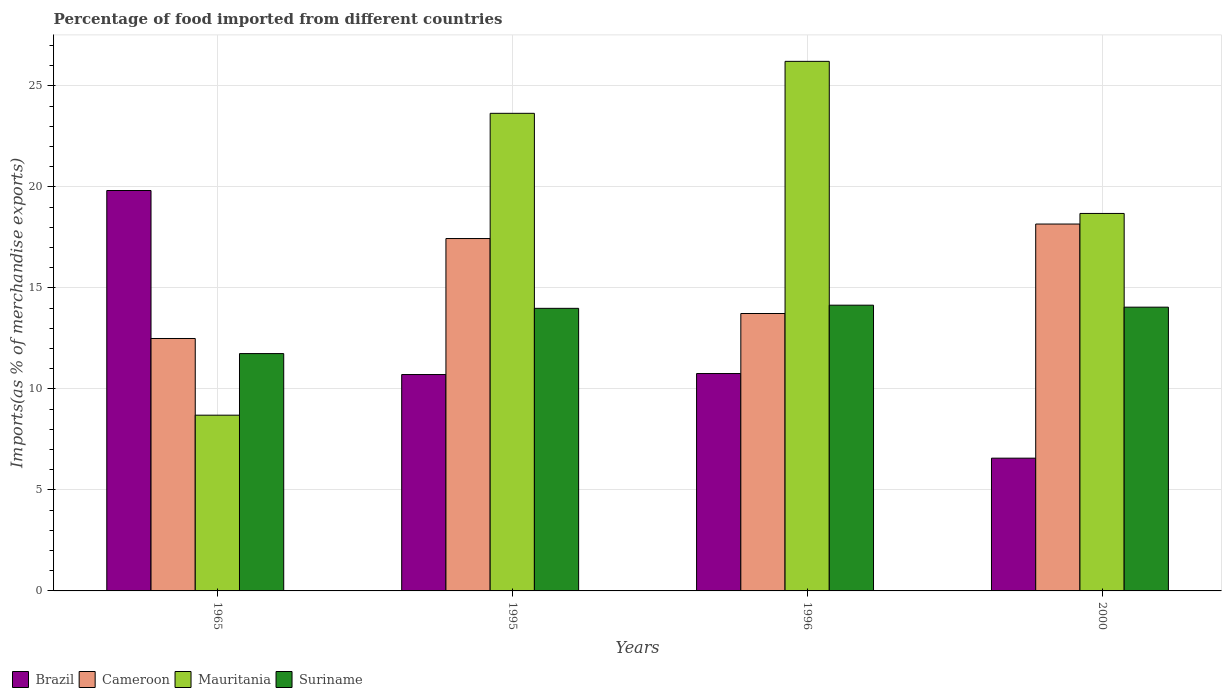How many different coloured bars are there?
Provide a short and direct response. 4. How many groups of bars are there?
Your answer should be very brief. 4. Are the number of bars on each tick of the X-axis equal?
Your answer should be very brief. Yes. How many bars are there on the 4th tick from the left?
Keep it short and to the point. 4. How many bars are there on the 2nd tick from the right?
Your answer should be very brief. 4. What is the percentage of imports to different countries in Suriname in 1995?
Make the answer very short. 13.99. Across all years, what is the maximum percentage of imports to different countries in Brazil?
Your response must be concise. 19.82. Across all years, what is the minimum percentage of imports to different countries in Suriname?
Provide a succinct answer. 11.75. In which year was the percentage of imports to different countries in Brazil maximum?
Provide a short and direct response. 1965. In which year was the percentage of imports to different countries in Cameroon minimum?
Give a very brief answer. 1965. What is the total percentage of imports to different countries in Suriname in the graph?
Offer a very short reply. 53.92. What is the difference between the percentage of imports to different countries in Brazil in 1965 and that in 2000?
Provide a short and direct response. 13.25. What is the difference between the percentage of imports to different countries in Cameroon in 2000 and the percentage of imports to different countries in Suriname in 1995?
Keep it short and to the point. 4.17. What is the average percentage of imports to different countries in Brazil per year?
Your answer should be very brief. 11.96. In the year 2000, what is the difference between the percentage of imports to different countries in Mauritania and percentage of imports to different countries in Cameroon?
Your answer should be very brief. 0.52. What is the ratio of the percentage of imports to different countries in Suriname in 1965 to that in 1995?
Provide a short and direct response. 0.84. Is the difference between the percentage of imports to different countries in Mauritania in 1965 and 2000 greater than the difference between the percentage of imports to different countries in Cameroon in 1965 and 2000?
Your response must be concise. No. What is the difference between the highest and the second highest percentage of imports to different countries in Brazil?
Give a very brief answer. 9.06. What is the difference between the highest and the lowest percentage of imports to different countries in Suriname?
Offer a very short reply. 2.4. In how many years, is the percentage of imports to different countries in Brazil greater than the average percentage of imports to different countries in Brazil taken over all years?
Ensure brevity in your answer.  1. Is the sum of the percentage of imports to different countries in Cameroon in 1965 and 1995 greater than the maximum percentage of imports to different countries in Suriname across all years?
Provide a succinct answer. Yes. What does the 4th bar from the right in 1995 represents?
Make the answer very short. Brazil. Is it the case that in every year, the sum of the percentage of imports to different countries in Mauritania and percentage of imports to different countries in Brazil is greater than the percentage of imports to different countries in Cameroon?
Your answer should be compact. Yes. Are all the bars in the graph horizontal?
Make the answer very short. No. What is the difference between two consecutive major ticks on the Y-axis?
Provide a succinct answer. 5. What is the title of the graph?
Provide a short and direct response. Percentage of food imported from different countries. Does "West Bank and Gaza" appear as one of the legend labels in the graph?
Your answer should be very brief. No. What is the label or title of the X-axis?
Provide a short and direct response. Years. What is the label or title of the Y-axis?
Ensure brevity in your answer.  Imports(as % of merchandise exports). What is the Imports(as % of merchandise exports) of Brazil in 1965?
Keep it short and to the point. 19.82. What is the Imports(as % of merchandise exports) of Cameroon in 1965?
Your response must be concise. 12.49. What is the Imports(as % of merchandise exports) of Mauritania in 1965?
Your response must be concise. 8.7. What is the Imports(as % of merchandise exports) of Suriname in 1965?
Provide a succinct answer. 11.75. What is the Imports(as % of merchandise exports) of Brazil in 1995?
Provide a short and direct response. 10.71. What is the Imports(as % of merchandise exports) of Cameroon in 1995?
Keep it short and to the point. 17.44. What is the Imports(as % of merchandise exports) in Mauritania in 1995?
Your response must be concise. 23.64. What is the Imports(as % of merchandise exports) of Suriname in 1995?
Your response must be concise. 13.99. What is the Imports(as % of merchandise exports) in Brazil in 1996?
Keep it short and to the point. 10.76. What is the Imports(as % of merchandise exports) in Cameroon in 1996?
Your answer should be compact. 13.73. What is the Imports(as % of merchandise exports) in Mauritania in 1996?
Ensure brevity in your answer.  26.21. What is the Imports(as % of merchandise exports) of Suriname in 1996?
Offer a terse response. 14.14. What is the Imports(as % of merchandise exports) in Brazil in 2000?
Offer a very short reply. 6.57. What is the Imports(as % of merchandise exports) in Cameroon in 2000?
Make the answer very short. 18.16. What is the Imports(as % of merchandise exports) in Mauritania in 2000?
Your response must be concise. 18.68. What is the Imports(as % of merchandise exports) of Suriname in 2000?
Provide a succinct answer. 14.04. Across all years, what is the maximum Imports(as % of merchandise exports) in Brazil?
Give a very brief answer. 19.82. Across all years, what is the maximum Imports(as % of merchandise exports) of Cameroon?
Provide a short and direct response. 18.16. Across all years, what is the maximum Imports(as % of merchandise exports) in Mauritania?
Provide a short and direct response. 26.21. Across all years, what is the maximum Imports(as % of merchandise exports) of Suriname?
Make the answer very short. 14.14. Across all years, what is the minimum Imports(as % of merchandise exports) in Brazil?
Offer a terse response. 6.57. Across all years, what is the minimum Imports(as % of merchandise exports) of Cameroon?
Give a very brief answer. 12.49. Across all years, what is the minimum Imports(as % of merchandise exports) in Mauritania?
Make the answer very short. 8.7. Across all years, what is the minimum Imports(as % of merchandise exports) in Suriname?
Provide a short and direct response. 11.75. What is the total Imports(as % of merchandise exports) of Brazil in the graph?
Keep it short and to the point. 47.86. What is the total Imports(as % of merchandise exports) in Cameroon in the graph?
Your answer should be compact. 61.82. What is the total Imports(as % of merchandise exports) in Mauritania in the graph?
Ensure brevity in your answer.  77.23. What is the total Imports(as % of merchandise exports) of Suriname in the graph?
Ensure brevity in your answer.  53.92. What is the difference between the Imports(as % of merchandise exports) in Brazil in 1965 and that in 1995?
Keep it short and to the point. 9.11. What is the difference between the Imports(as % of merchandise exports) in Cameroon in 1965 and that in 1995?
Keep it short and to the point. -4.95. What is the difference between the Imports(as % of merchandise exports) in Mauritania in 1965 and that in 1995?
Your answer should be very brief. -14.94. What is the difference between the Imports(as % of merchandise exports) in Suriname in 1965 and that in 1995?
Make the answer very short. -2.24. What is the difference between the Imports(as % of merchandise exports) of Brazil in 1965 and that in 1996?
Ensure brevity in your answer.  9.06. What is the difference between the Imports(as % of merchandise exports) in Cameroon in 1965 and that in 1996?
Give a very brief answer. -1.24. What is the difference between the Imports(as % of merchandise exports) in Mauritania in 1965 and that in 1996?
Make the answer very short. -17.51. What is the difference between the Imports(as % of merchandise exports) in Suriname in 1965 and that in 1996?
Provide a succinct answer. -2.4. What is the difference between the Imports(as % of merchandise exports) in Brazil in 1965 and that in 2000?
Give a very brief answer. 13.25. What is the difference between the Imports(as % of merchandise exports) of Cameroon in 1965 and that in 2000?
Ensure brevity in your answer.  -5.66. What is the difference between the Imports(as % of merchandise exports) in Mauritania in 1965 and that in 2000?
Keep it short and to the point. -9.98. What is the difference between the Imports(as % of merchandise exports) in Suriname in 1965 and that in 2000?
Ensure brevity in your answer.  -2.3. What is the difference between the Imports(as % of merchandise exports) in Brazil in 1995 and that in 1996?
Your answer should be compact. -0.05. What is the difference between the Imports(as % of merchandise exports) of Cameroon in 1995 and that in 1996?
Offer a terse response. 3.71. What is the difference between the Imports(as % of merchandise exports) in Mauritania in 1995 and that in 1996?
Your answer should be compact. -2.57. What is the difference between the Imports(as % of merchandise exports) in Suriname in 1995 and that in 1996?
Your response must be concise. -0.16. What is the difference between the Imports(as % of merchandise exports) of Brazil in 1995 and that in 2000?
Provide a short and direct response. 4.14. What is the difference between the Imports(as % of merchandise exports) of Cameroon in 1995 and that in 2000?
Provide a succinct answer. -0.72. What is the difference between the Imports(as % of merchandise exports) in Mauritania in 1995 and that in 2000?
Offer a very short reply. 4.96. What is the difference between the Imports(as % of merchandise exports) in Suriname in 1995 and that in 2000?
Your answer should be very brief. -0.06. What is the difference between the Imports(as % of merchandise exports) of Brazil in 1996 and that in 2000?
Your answer should be very brief. 4.19. What is the difference between the Imports(as % of merchandise exports) in Cameroon in 1996 and that in 2000?
Give a very brief answer. -4.43. What is the difference between the Imports(as % of merchandise exports) in Mauritania in 1996 and that in 2000?
Offer a very short reply. 7.53. What is the difference between the Imports(as % of merchandise exports) of Suriname in 1996 and that in 2000?
Give a very brief answer. 0.1. What is the difference between the Imports(as % of merchandise exports) in Brazil in 1965 and the Imports(as % of merchandise exports) in Cameroon in 1995?
Give a very brief answer. 2.38. What is the difference between the Imports(as % of merchandise exports) in Brazil in 1965 and the Imports(as % of merchandise exports) in Mauritania in 1995?
Ensure brevity in your answer.  -3.82. What is the difference between the Imports(as % of merchandise exports) of Brazil in 1965 and the Imports(as % of merchandise exports) of Suriname in 1995?
Give a very brief answer. 5.83. What is the difference between the Imports(as % of merchandise exports) in Cameroon in 1965 and the Imports(as % of merchandise exports) in Mauritania in 1995?
Your answer should be very brief. -11.14. What is the difference between the Imports(as % of merchandise exports) in Cameroon in 1965 and the Imports(as % of merchandise exports) in Suriname in 1995?
Your answer should be compact. -1.49. What is the difference between the Imports(as % of merchandise exports) of Mauritania in 1965 and the Imports(as % of merchandise exports) of Suriname in 1995?
Ensure brevity in your answer.  -5.29. What is the difference between the Imports(as % of merchandise exports) of Brazil in 1965 and the Imports(as % of merchandise exports) of Cameroon in 1996?
Offer a terse response. 6.09. What is the difference between the Imports(as % of merchandise exports) of Brazil in 1965 and the Imports(as % of merchandise exports) of Mauritania in 1996?
Keep it short and to the point. -6.39. What is the difference between the Imports(as % of merchandise exports) of Brazil in 1965 and the Imports(as % of merchandise exports) of Suriname in 1996?
Provide a succinct answer. 5.68. What is the difference between the Imports(as % of merchandise exports) in Cameroon in 1965 and the Imports(as % of merchandise exports) in Mauritania in 1996?
Provide a short and direct response. -13.72. What is the difference between the Imports(as % of merchandise exports) in Cameroon in 1965 and the Imports(as % of merchandise exports) in Suriname in 1996?
Ensure brevity in your answer.  -1.65. What is the difference between the Imports(as % of merchandise exports) in Mauritania in 1965 and the Imports(as % of merchandise exports) in Suriname in 1996?
Offer a very short reply. -5.44. What is the difference between the Imports(as % of merchandise exports) in Brazil in 1965 and the Imports(as % of merchandise exports) in Cameroon in 2000?
Keep it short and to the point. 1.66. What is the difference between the Imports(as % of merchandise exports) in Brazil in 1965 and the Imports(as % of merchandise exports) in Mauritania in 2000?
Provide a short and direct response. 1.14. What is the difference between the Imports(as % of merchandise exports) of Brazil in 1965 and the Imports(as % of merchandise exports) of Suriname in 2000?
Make the answer very short. 5.77. What is the difference between the Imports(as % of merchandise exports) in Cameroon in 1965 and the Imports(as % of merchandise exports) in Mauritania in 2000?
Give a very brief answer. -6.19. What is the difference between the Imports(as % of merchandise exports) of Cameroon in 1965 and the Imports(as % of merchandise exports) of Suriname in 2000?
Give a very brief answer. -1.55. What is the difference between the Imports(as % of merchandise exports) of Mauritania in 1965 and the Imports(as % of merchandise exports) of Suriname in 2000?
Provide a short and direct response. -5.35. What is the difference between the Imports(as % of merchandise exports) in Brazil in 1995 and the Imports(as % of merchandise exports) in Cameroon in 1996?
Keep it short and to the point. -3.02. What is the difference between the Imports(as % of merchandise exports) of Brazil in 1995 and the Imports(as % of merchandise exports) of Mauritania in 1996?
Provide a short and direct response. -15.5. What is the difference between the Imports(as % of merchandise exports) in Brazil in 1995 and the Imports(as % of merchandise exports) in Suriname in 1996?
Give a very brief answer. -3.43. What is the difference between the Imports(as % of merchandise exports) in Cameroon in 1995 and the Imports(as % of merchandise exports) in Mauritania in 1996?
Offer a very short reply. -8.77. What is the difference between the Imports(as % of merchandise exports) of Cameroon in 1995 and the Imports(as % of merchandise exports) of Suriname in 1996?
Offer a very short reply. 3.3. What is the difference between the Imports(as % of merchandise exports) in Mauritania in 1995 and the Imports(as % of merchandise exports) in Suriname in 1996?
Provide a short and direct response. 9.5. What is the difference between the Imports(as % of merchandise exports) in Brazil in 1995 and the Imports(as % of merchandise exports) in Cameroon in 2000?
Provide a short and direct response. -7.45. What is the difference between the Imports(as % of merchandise exports) in Brazil in 1995 and the Imports(as % of merchandise exports) in Mauritania in 2000?
Your answer should be compact. -7.97. What is the difference between the Imports(as % of merchandise exports) of Brazil in 1995 and the Imports(as % of merchandise exports) of Suriname in 2000?
Your response must be concise. -3.33. What is the difference between the Imports(as % of merchandise exports) of Cameroon in 1995 and the Imports(as % of merchandise exports) of Mauritania in 2000?
Give a very brief answer. -1.24. What is the difference between the Imports(as % of merchandise exports) in Cameroon in 1995 and the Imports(as % of merchandise exports) in Suriname in 2000?
Offer a terse response. 3.4. What is the difference between the Imports(as % of merchandise exports) in Mauritania in 1995 and the Imports(as % of merchandise exports) in Suriname in 2000?
Your response must be concise. 9.59. What is the difference between the Imports(as % of merchandise exports) of Brazil in 1996 and the Imports(as % of merchandise exports) of Cameroon in 2000?
Your answer should be very brief. -7.4. What is the difference between the Imports(as % of merchandise exports) in Brazil in 1996 and the Imports(as % of merchandise exports) in Mauritania in 2000?
Provide a succinct answer. -7.92. What is the difference between the Imports(as % of merchandise exports) in Brazil in 1996 and the Imports(as % of merchandise exports) in Suriname in 2000?
Offer a terse response. -3.29. What is the difference between the Imports(as % of merchandise exports) of Cameroon in 1996 and the Imports(as % of merchandise exports) of Mauritania in 2000?
Ensure brevity in your answer.  -4.95. What is the difference between the Imports(as % of merchandise exports) in Cameroon in 1996 and the Imports(as % of merchandise exports) in Suriname in 2000?
Your response must be concise. -0.31. What is the difference between the Imports(as % of merchandise exports) in Mauritania in 1996 and the Imports(as % of merchandise exports) in Suriname in 2000?
Your response must be concise. 12.17. What is the average Imports(as % of merchandise exports) of Brazil per year?
Your answer should be very brief. 11.96. What is the average Imports(as % of merchandise exports) in Cameroon per year?
Your response must be concise. 15.46. What is the average Imports(as % of merchandise exports) in Mauritania per year?
Provide a short and direct response. 19.31. What is the average Imports(as % of merchandise exports) of Suriname per year?
Your answer should be very brief. 13.48. In the year 1965, what is the difference between the Imports(as % of merchandise exports) in Brazil and Imports(as % of merchandise exports) in Cameroon?
Give a very brief answer. 7.32. In the year 1965, what is the difference between the Imports(as % of merchandise exports) of Brazil and Imports(as % of merchandise exports) of Mauritania?
Your answer should be very brief. 11.12. In the year 1965, what is the difference between the Imports(as % of merchandise exports) in Brazil and Imports(as % of merchandise exports) in Suriname?
Give a very brief answer. 8.07. In the year 1965, what is the difference between the Imports(as % of merchandise exports) in Cameroon and Imports(as % of merchandise exports) in Mauritania?
Offer a terse response. 3.8. In the year 1965, what is the difference between the Imports(as % of merchandise exports) in Cameroon and Imports(as % of merchandise exports) in Suriname?
Provide a short and direct response. 0.75. In the year 1965, what is the difference between the Imports(as % of merchandise exports) in Mauritania and Imports(as % of merchandise exports) in Suriname?
Give a very brief answer. -3.05. In the year 1995, what is the difference between the Imports(as % of merchandise exports) of Brazil and Imports(as % of merchandise exports) of Cameroon?
Make the answer very short. -6.73. In the year 1995, what is the difference between the Imports(as % of merchandise exports) in Brazil and Imports(as % of merchandise exports) in Mauritania?
Provide a succinct answer. -12.93. In the year 1995, what is the difference between the Imports(as % of merchandise exports) of Brazil and Imports(as % of merchandise exports) of Suriname?
Ensure brevity in your answer.  -3.28. In the year 1995, what is the difference between the Imports(as % of merchandise exports) in Cameroon and Imports(as % of merchandise exports) in Mauritania?
Provide a succinct answer. -6.2. In the year 1995, what is the difference between the Imports(as % of merchandise exports) in Cameroon and Imports(as % of merchandise exports) in Suriname?
Your answer should be very brief. 3.45. In the year 1995, what is the difference between the Imports(as % of merchandise exports) of Mauritania and Imports(as % of merchandise exports) of Suriname?
Give a very brief answer. 9.65. In the year 1996, what is the difference between the Imports(as % of merchandise exports) of Brazil and Imports(as % of merchandise exports) of Cameroon?
Your answer should be very brief. -2.97. In the year 1996, what is the difference between the Imports(as % of merchandise exports) in Brazil and Imports(as % of merchandise exports) in Mauritania?
Ensure brevity in your answer.  -15.45. In the year 1996, what is the difference between the Imports(as % of merchandise exports) in Brazil and Imports(as % of merchandise exports) in Suriname?
Offer a very short reply. -3.38. In the year 1996, what is the difference between the Imports(as % of merchandise exports) of Cameroon and Imports(as % of merchandise exports) of Mauritania?
Give a very brief answer. -12.48. In the year 1996, what is the difference between the Imports(as % of merchandise exports) of Cameroon and Imports(as % of merchandise exports) of Suriname?
Keep it short and to the point. -0.41. In the year 1996, what is the difference between the Imports(as % of merchandise exports) of Mauritania and Imports(as % of merchandise exports) of Suriname?
Provide a succinct answer. 12.07. In the year 2000, what is the difference between the Imports(as % of merchandise exports) in Brazil and Imports(as % of merchandise exports) in Cameroon?
Your answer should be compact. -11.59. In the year 2000, what is the difference between the Imports(as % of merchandise exports) in Brazil and Imports(as % of merchandise exports) in Mauritania?
Provide a succinct answer. -12.11. In the year 2000, what is the difference between the Imports(as % of merchandise exports) in Brazil and Imports(as % of merchandise exports) in Suriname?
Your answer should be compact. -7.47. In the year 2000, what is the difference between the Imports(as % of merchandise exports) of Cameroon and Imports(as % of merchandise exports) of Mauritania?
Make the answer very short. -0.52. In the year 2000, what is the difference between the Imports(as % of merchandise exports) in Cameroon and Imports(as % of merchandise exports) in Suriname?
Your response must be concise. 4.11. In the year 2000, what is the difference between the Imports(as % of merchandise exports) of Mauritania and Imports(as % of merchandise exports) of Suriname?
Your answer should be compact. 4.64. What is the ratio of the Imports(as % of merchandise exports) in Brazil in 1965 to that in 1995?
Your answer should be compact. 1.85. What is the ratio of the Imports(as % of merchandise exports) in Cameroon in 1965 to that in 1995?
Give a very brief answer. 0.72. What is the ratio of the Imports(as % of merchandise exports) of Mauritania in 1965 to that in 1995?
Offer a terse response. 0.37. What is the ratio of the Imports(as % of merchandise exports) in Suriname in 1965 to that in 1995?
Offer a very short reply. 0.84. What is the ratio of the Imports(as % of merchandise exports) of Brazil in 1965 to that in 1996?
Make the answer very short. 1.84. What is the ratio of the Imports(as % of merchandise exports) of Cameroon in 1965 to that in 1996?
Your response must be concise. 0.91. What is the ratio of the Imports(as % of merchandise exports) in Mauritania in 1965 to that in 1996?
Provide a succinct answer. 0.33. What is the ratio of the Imports(as % of merchandise exports) in Suriname in 1965 to that in 1996?
Offer a very short reply. 0.83. What is the ratio of the Imports(as % of merchandise exports) in Brazil in 1965 to that in 2000?
Ensure brevity in your answer.  3.02. What is the ratio of the Imports(as % of merchandise exports) of Cameroon in 1965 to that in 2000?
Provide a succinct answer. 0.69. What is the ratio of the Imports(as % of merchandise exports) in Mauritania in 1965 to that in 2000?
Provide a short and direct response. 0.47. What is the ratio of the Imports(as % of merchandise exports) in Suriname in 1965 to that in 2000?
Offer a very short reply. 0.84. What is the ratio of the Imports(as % of merchandise exports) in Brazil in 1995 to that in 1996?
Your response must be concise. 1. What is the ratio of the Imports(as % of merchandise exports) in Cameroon in 1995 to that in 1996?
Provide a short and direct response. 1.27. What is the ratio of the Imports(as % of merchandise exports) of Mauritania in 1995 to that in 1996?
Your response must be concise. 0.9. What is the ratio of the Imports(as % of merchandise exports) of Suriname in 1995 to that in 1996?
Your answer should be very brief. 0.99. What is the ratio of the Imports(as % of merchandise exports) in Brazil in 1995 to that in 2000?
Give a very brief answer. 1.63. What is the ratio of the Imports(as % of merchandise exports) of Cameroon in 1995 to that in 2000?
Ensure brevity in your answer.  0.96. What is the ratio of the Imports(as % of merchandise exports) of Mauritania in 1995 to that in 2000?
Provide a short and direct response. 1.27. What is the ratio of the Imports(as % of merchandise exports) in Suriname in 1995 to that in 2000?
Your answer should be very brief. 1. What is the ratio of the Imports(as % of merchandise exports) of Brazil in 1996 to that in 2000?
Offer a terse response. 1.64. What is the ratio of the Imports(as % of merchandise exports) of Cameroon in 1996 to that in 2000?
Offer a very short reply. 0.76. What is the ratio of the Imports(as % of merchandise exports) in Mauritania in 1996 to that in 2000?
Make the answer very short. 1.4. What is the difference between the highest and the second highest Imports(as % of merchandise exports) of Brazil?
Keep it short and to the point. 9.06. What is the difference between the highest and the second highest Imports(as % of merchandise exports) in Cameroon?
Your answer should be compact. 0.72. What is the difference between the highest and the second highest Imports(as % of merchandise exports) of Mauritania?
Your response must be concise. 2.57. What is the difference between the highest and the second highest Imports(as % of merchandise exports) in Suriname?
Provide a short and direct response. 0.1. What is the difference between the highest and the lowest Imports(as % of merchandise exports) in Brazil?
Make the answer very short. 13.25. What is the difference between the highest and the lowest Imports(as % of merchandise exports) of Cameroon?
Give a very brief answer. 5.66. What is the difference between the highest and the lowest Imports(as % of merchandise exports) in Mauritania?
Make the answer very short. 17.51. What is the difference between the highest and the lowest Imports(as % of merchandise exports) of Suriname?
Keep it short and to the point. 2.4. 